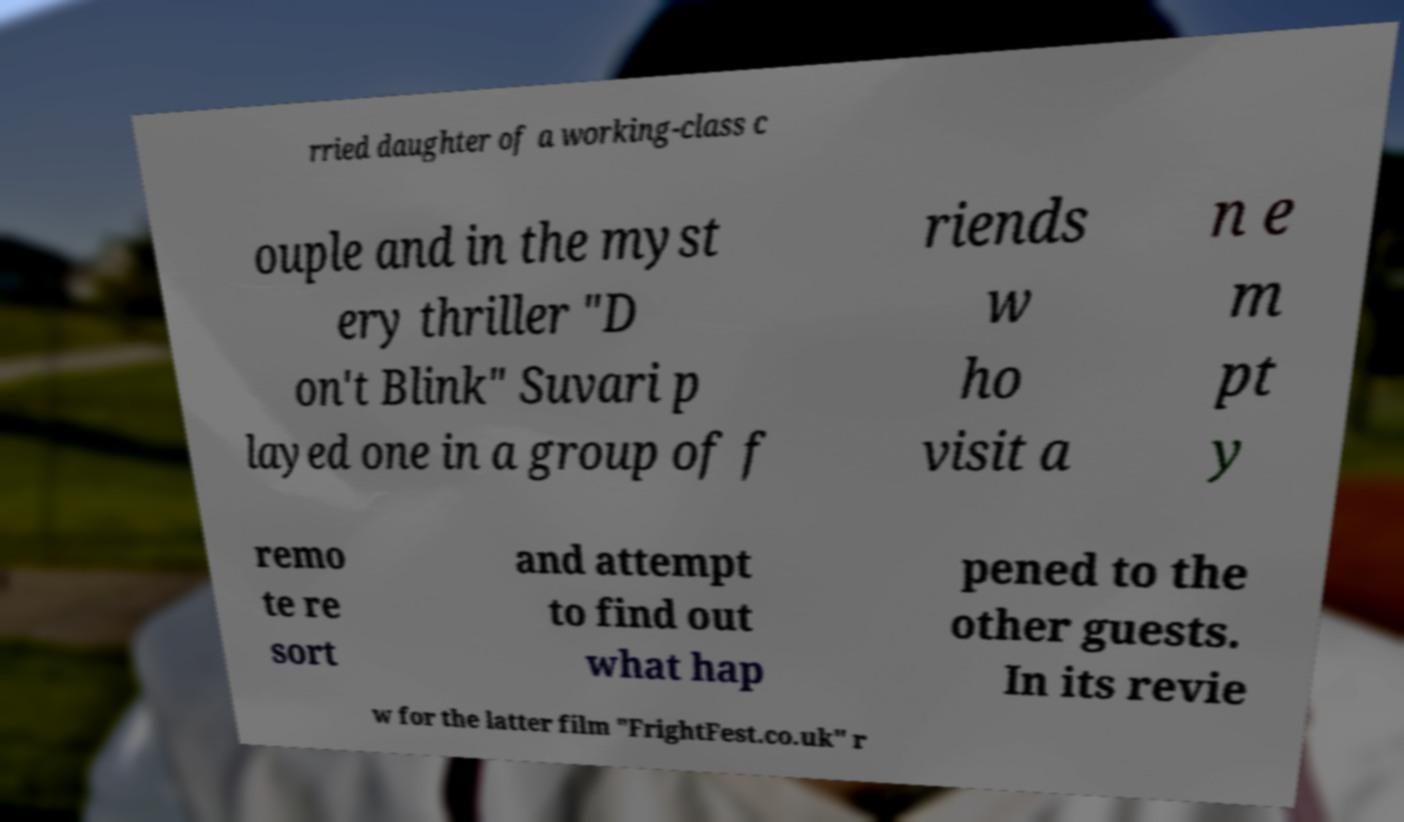Please read and relay the text visible in this image. What does it say? rried daughter of a working-class c ouple and in the myst ery thriller "D on't Blink" Suvari p layed one in a group of f riends w ho visit a n e m pt y remo te re sort and attempt to find out what hap pened to the other guests. In its revie w for the latter film "FrightFest.co.uk" r 